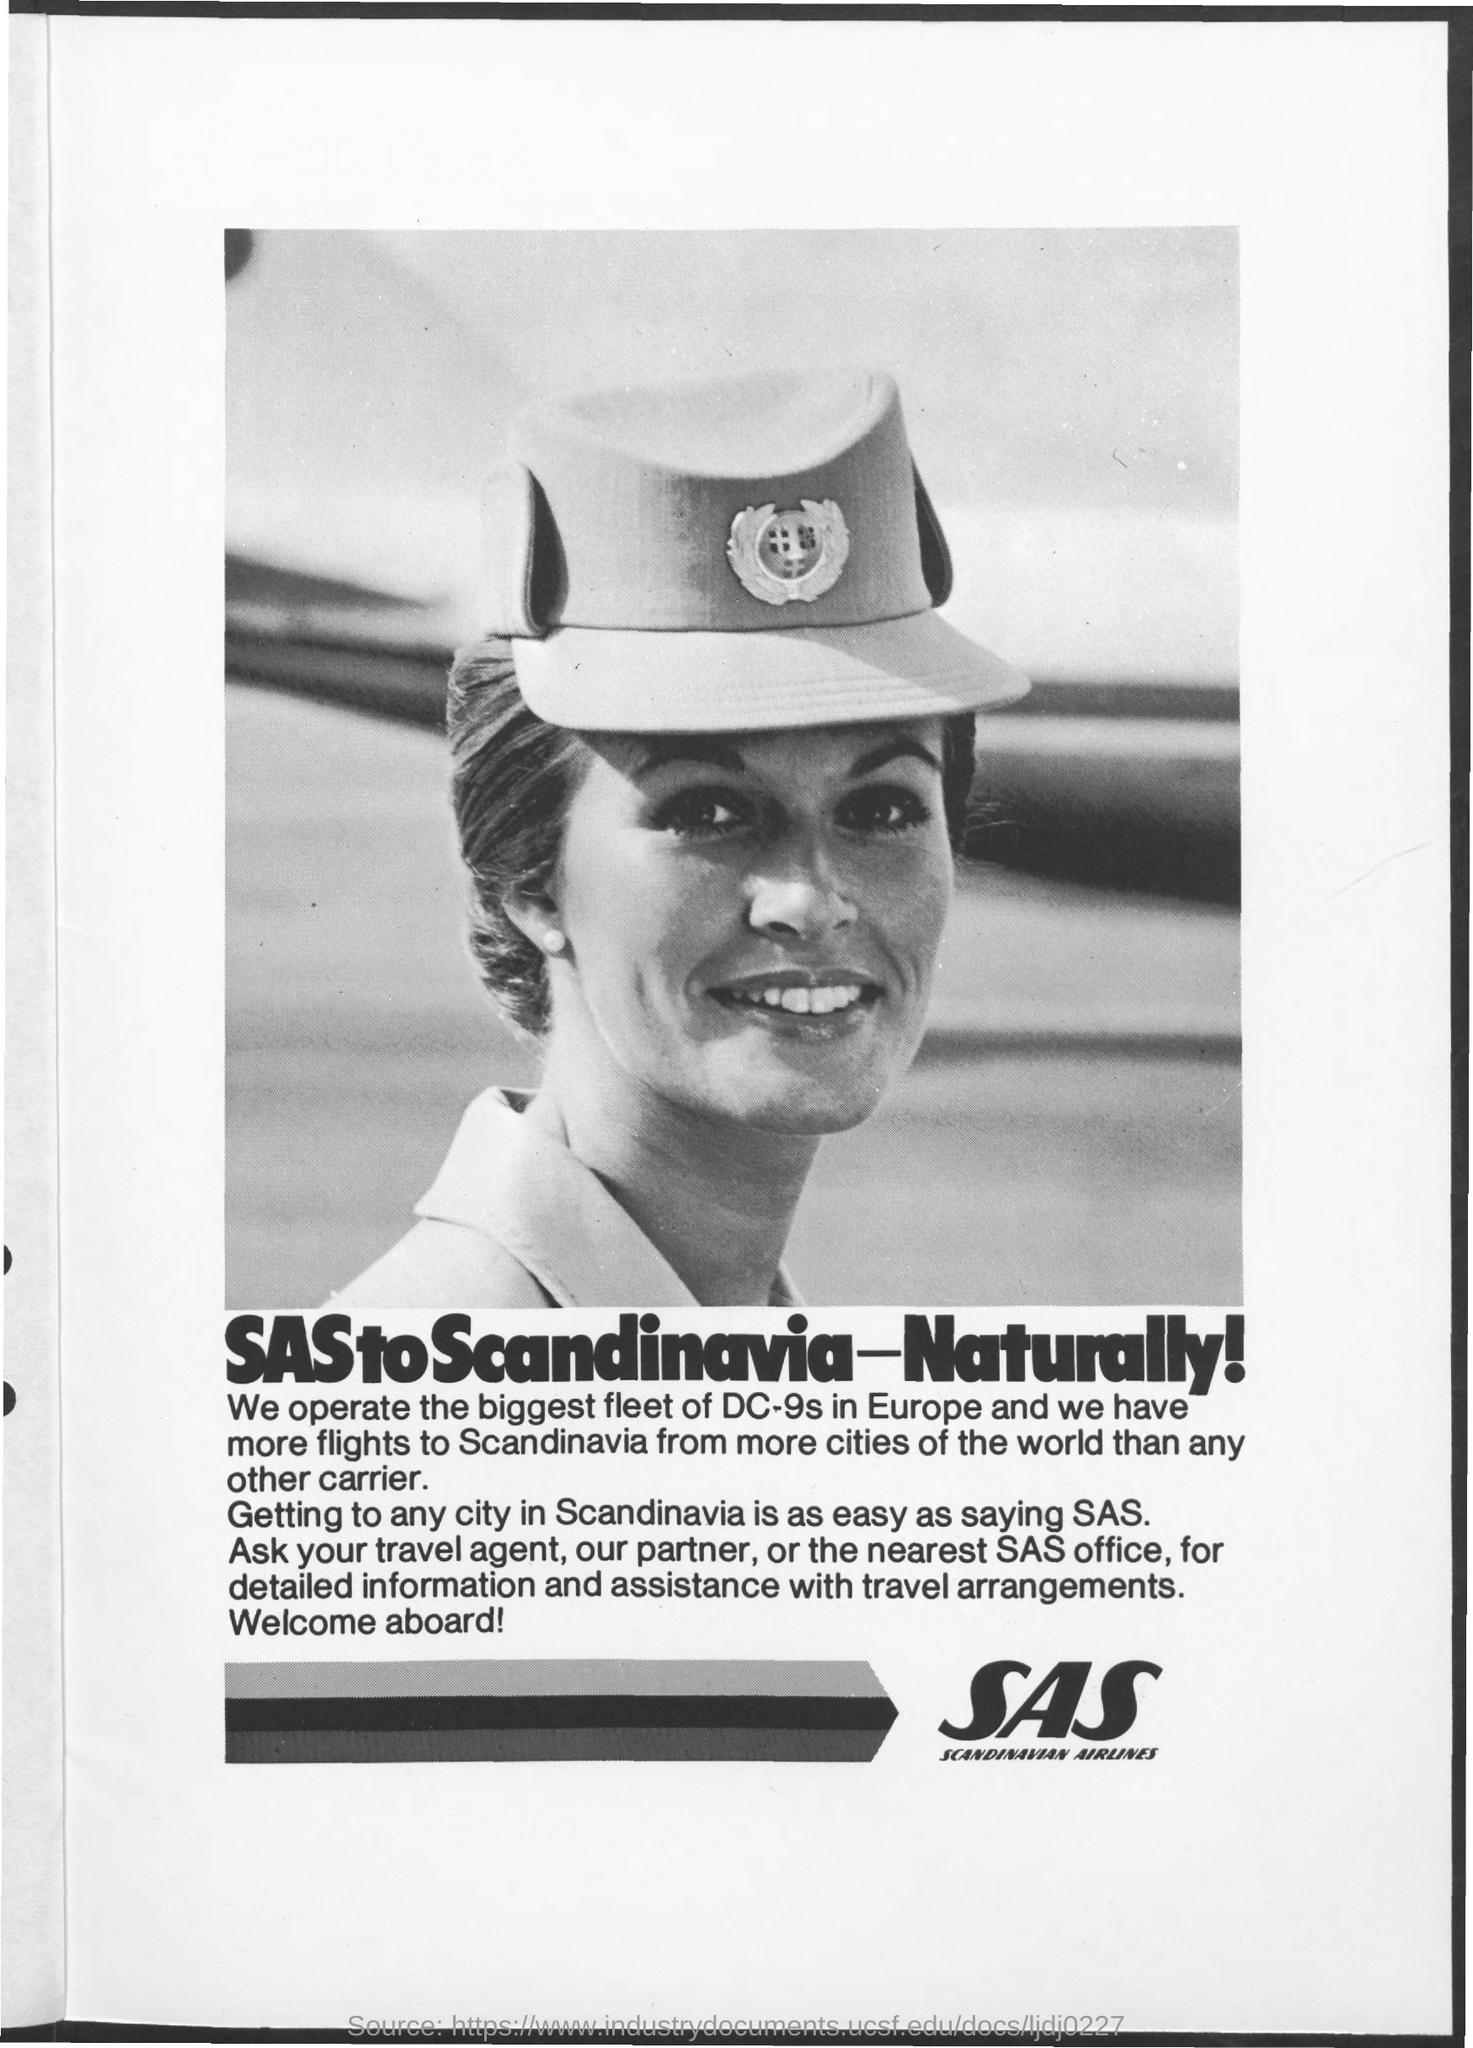Highlight a few significant elements in this photo. The SAS office should be approached for detailed information and assistance with travel arrangements. Scandinavian Airlines, also known as SAS, is a Swedish airline that provides passenger and cargo services to destinations worldwide. 